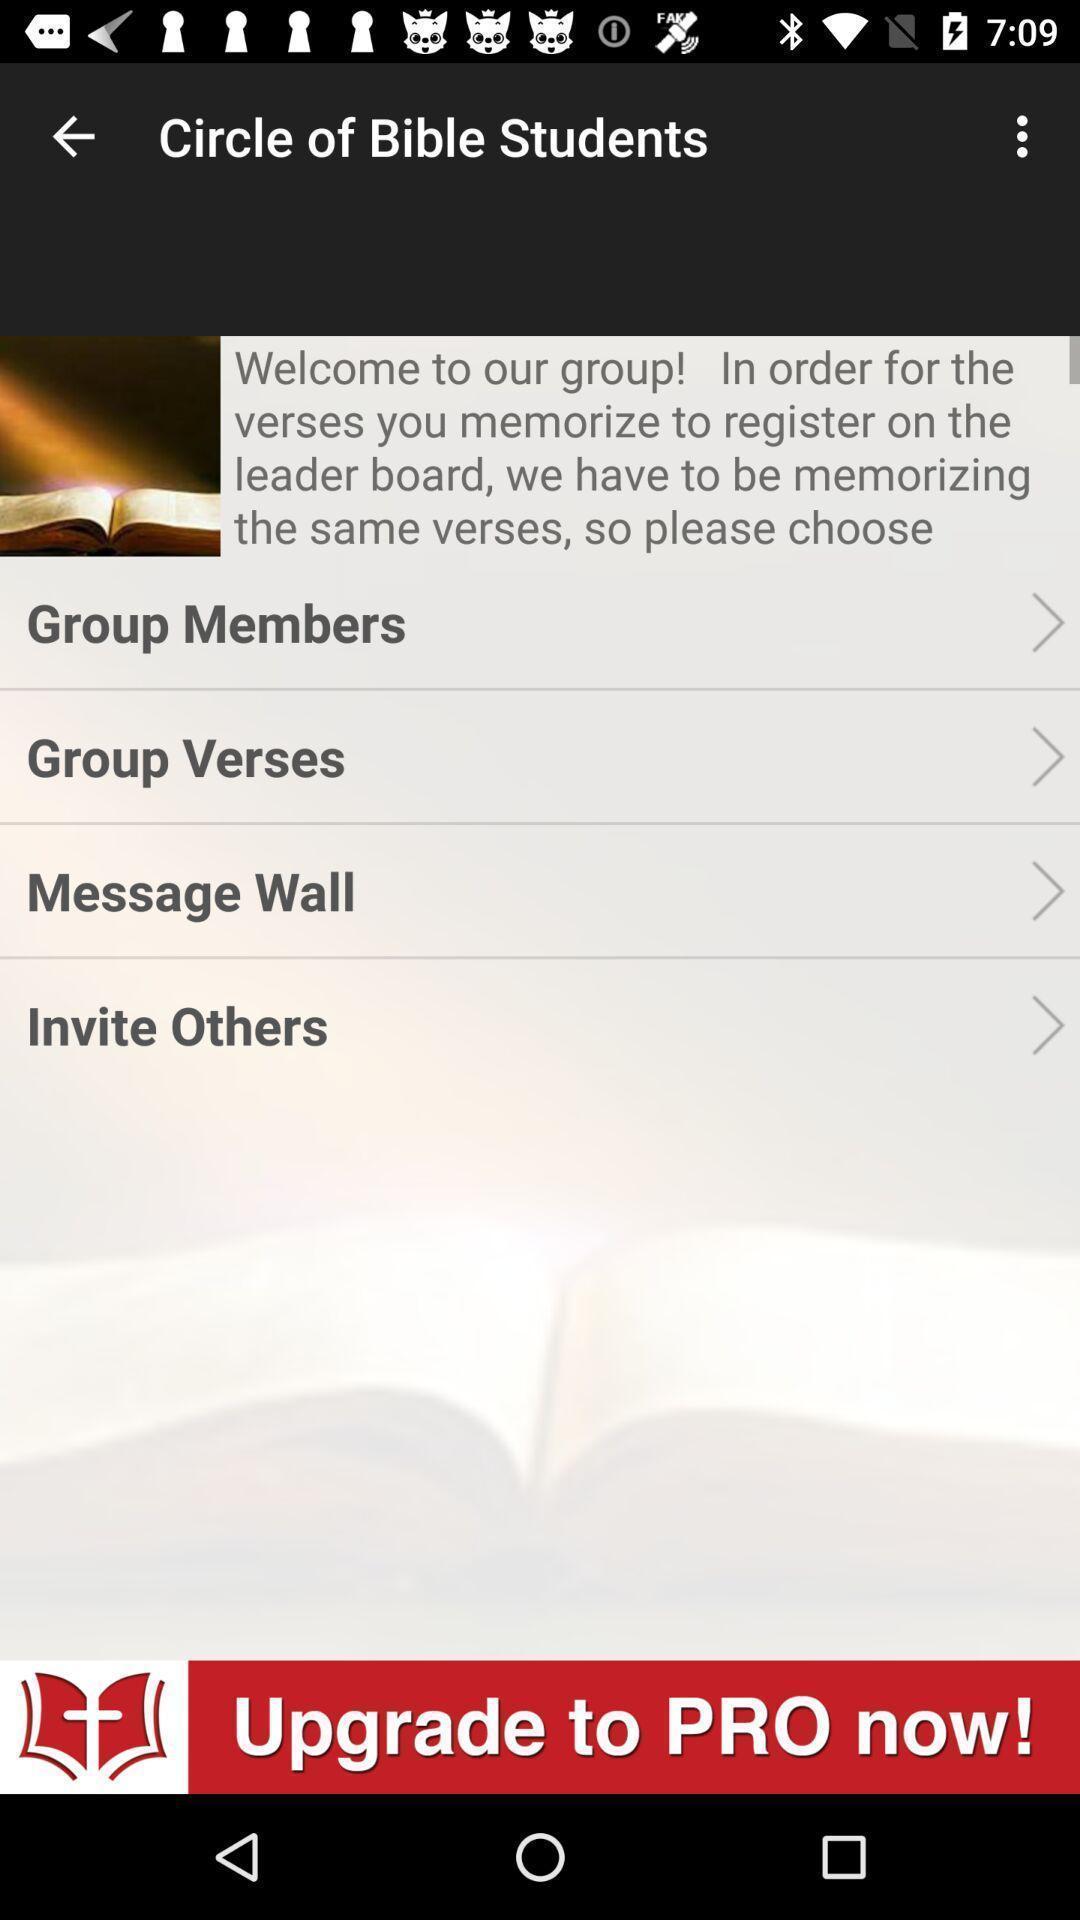Provide a detailed account of this screenshot. Welcome page. 